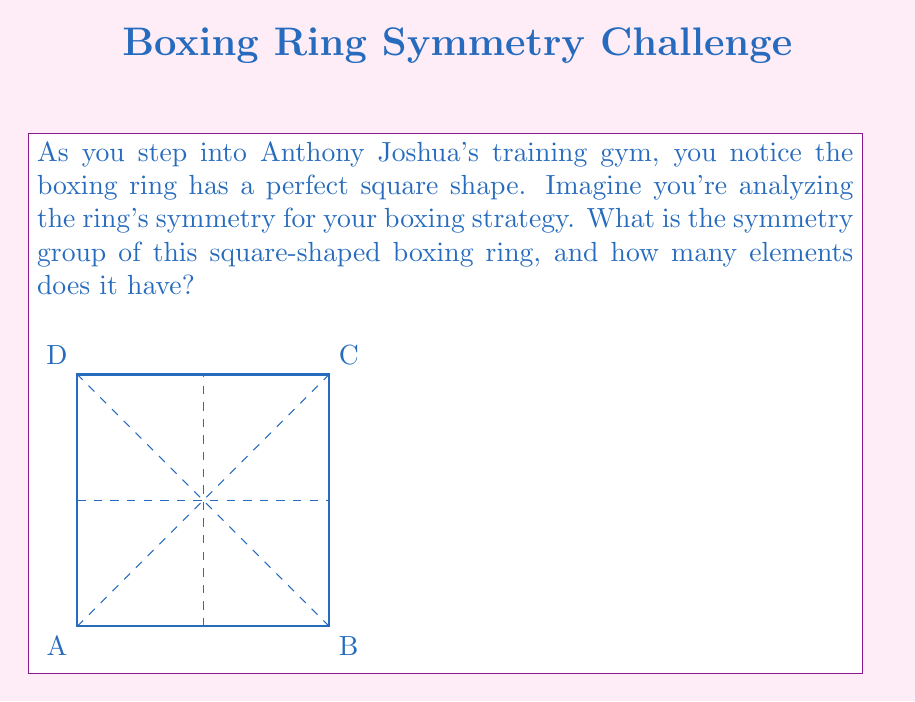Give your solution to this math problem. Let's approach this step-by-step:

1) The symmetry group of a square is known as the dihedral group of order 8, denoted as $D_4$ or $D_8$ (depending on the notation system).

2) The elements of this group consist of:
   a) The identity transformation (do nothing)
   b) Rotations by 90°, 180°, and 270° clockwise around the center
   c) Reflections across four lines: two diagonals and two perpendicular bisectors

3) Let's count these symmetries:
   - 1 identity transformation
   - 3 rotations (90°, 180°, 270°)
   - 4 reflections (2 diagonals + 2 perpendicular bisectors)

4) In total, we have 1 + 3 + 4 = 8 elements in the symmetry group.

5) The group operation is composition of these transformations, which satisfies the group axioms (closure, associativity, identity, and inverses).

6) In boxing terms, this means there are 8 ways you can view the ring that will look identical to its original position, which could be useful for visualizing different fight strategies or movement patterns.
Answer: $D_4$ (or $D_8$), with 8 elements 